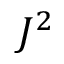Convert formula to latex. <formula><loc_0><loc_0><loc_500><loc_500>J ^ { 2 }</formula> 